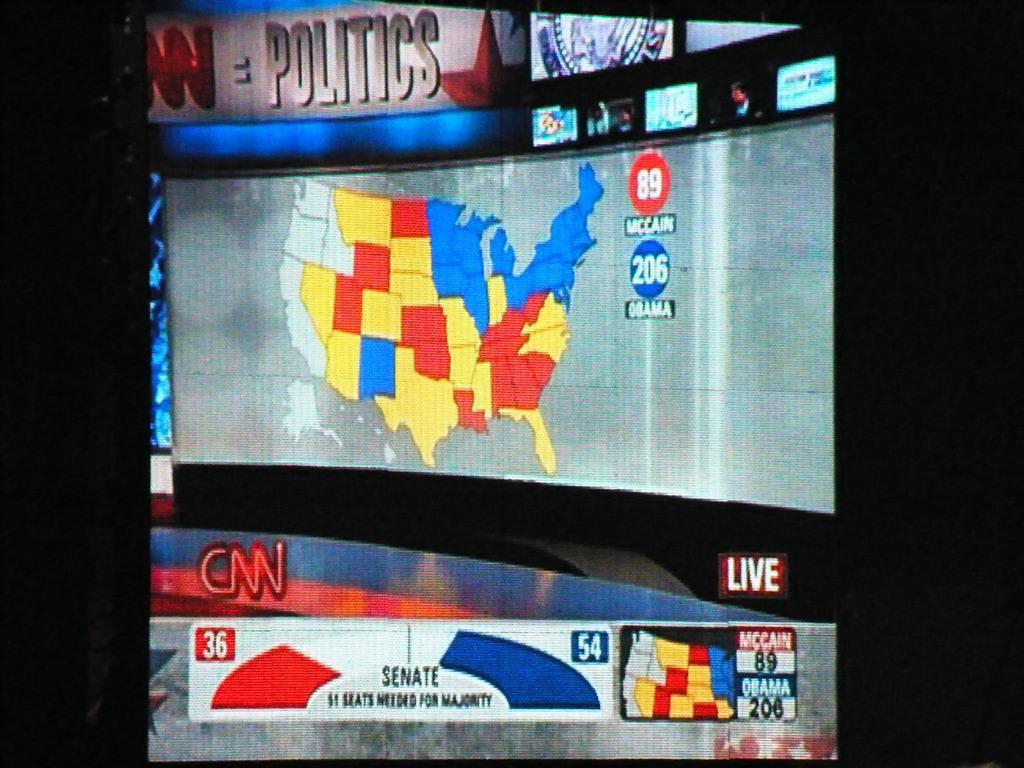<image>
Summarize the visual content of the image. a CNN logo with a map that is above it 